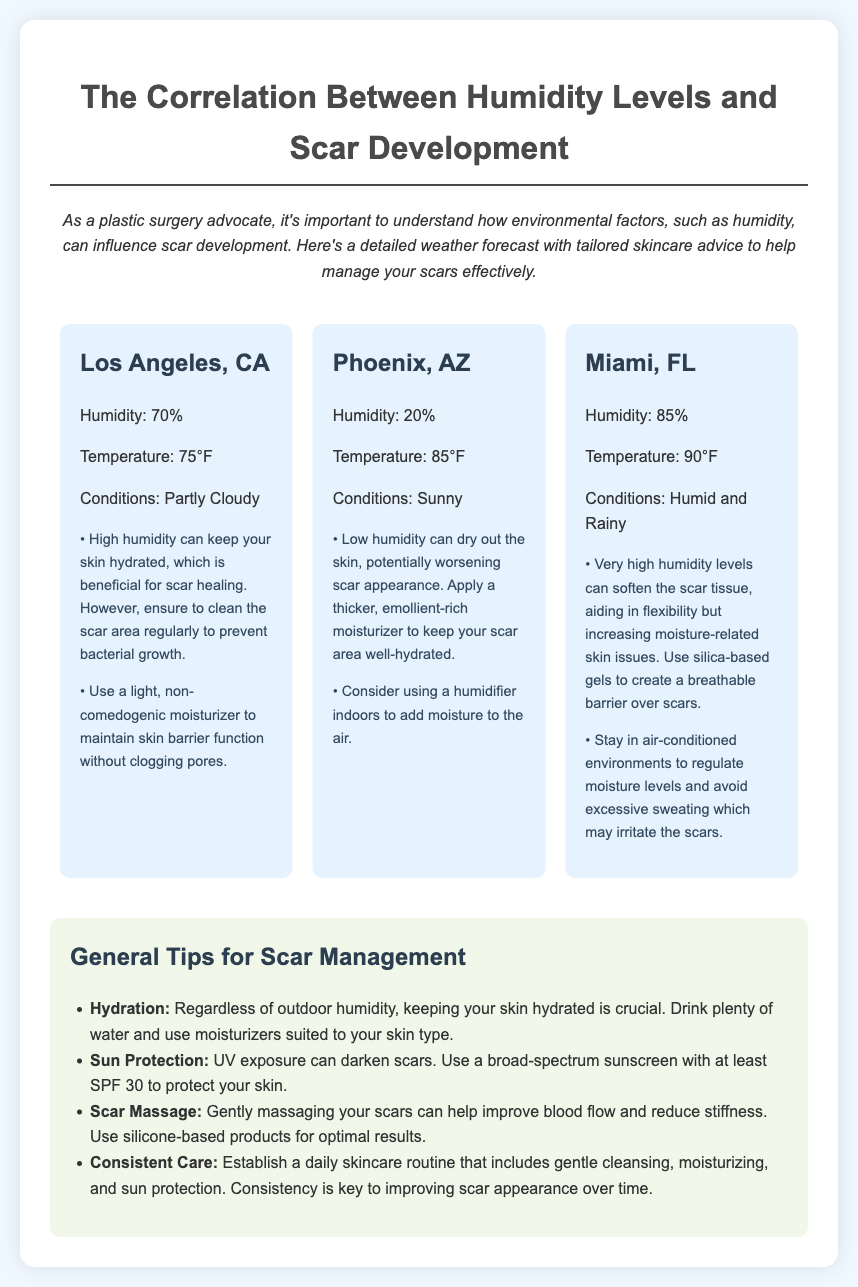What is the humidity level in Los Angeles? The humidity level in Los Angeles is mentioned in the weather information section of the document.
Answer: 70% What skincare advice is given for low humidity? The advice for low humidity is provided in the section regarding Phoenix, AZ, discussing how to manage scars in dry conditions.
Answer: Apply a thicker, emollient-rich moisturizer What temperature is reported for Miami? The temperature in Miami is included in the weather information for that city.
Answer: 90°F Which city has the highest humidity? The humidity levels are specified for each city, allowing for a comparison to identify the highest.
Answer: Miami, FL What is a general tip for hydration? The general tips section contains a specific recommendation about hydration regarding scar care.
Answer: Drink plenty of water What can be used to protect scars from UV exposure? The document provides a recommendation for sun protection as part of scar management.
Answer: Broad-spectrum sunscreen How should scars be massaged for optimal results? The information on scar massage provides specific advice on what product to use during the massage.
Answer: Silicone-based products What is the weather condition in Phoenix? The weather conditions are indicated for each city, including Phoenix.
Answer: Sunny 